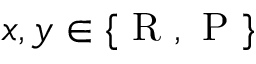Convert formula to latex. <formula><loc_0><loc_0><loc_500><loc_500>x , y \in \{ R , P \}</formula> 